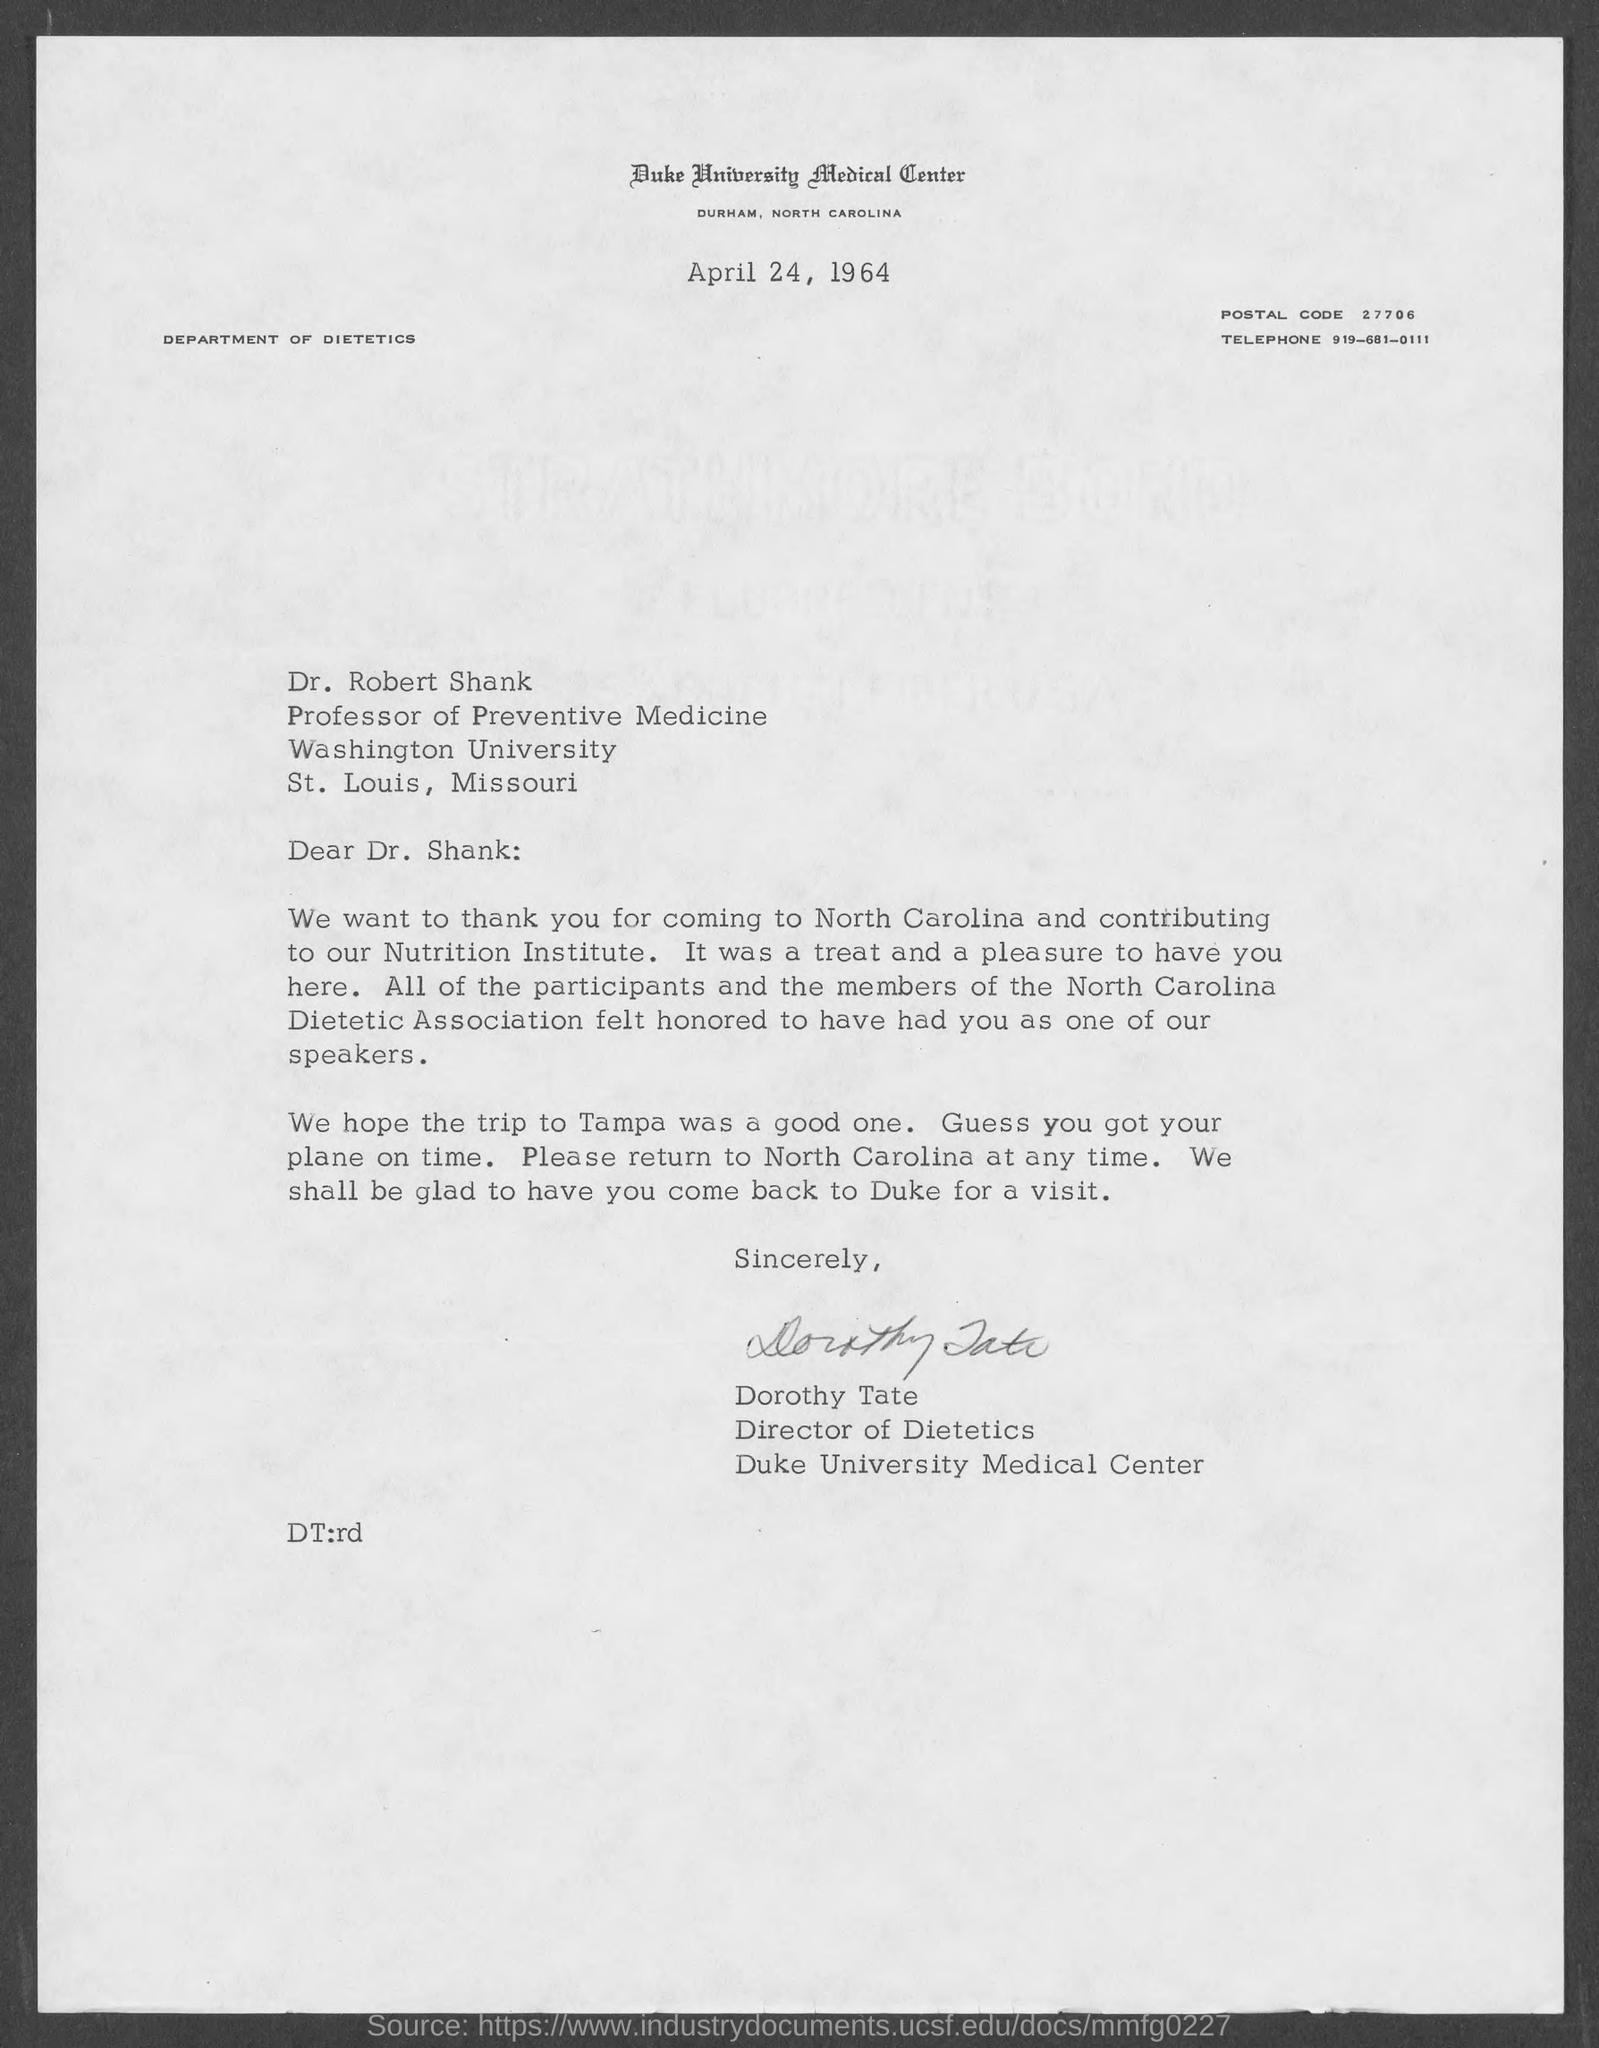Mention a couple of crucial points in this snapshot. Dr. Robert Shank holds the designation of Professor of Preventive Medicine. The telephone number is 919-681-0111. Washington University is located in St. Louis, Missouri. This letter is addressed to Dr. Shank. Duke University Medical Center is located in Durham, North Carolina. 